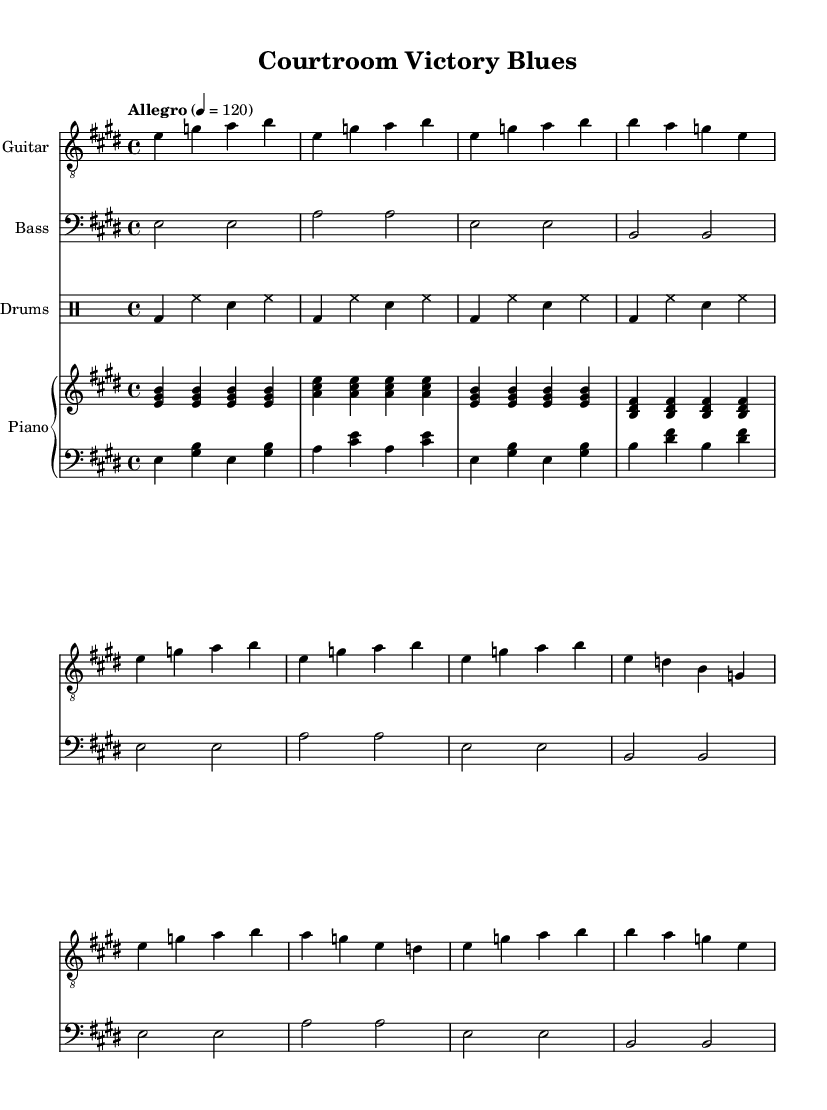What is the key signature of this music? The key signature is E major, which contains four sharps (F#, C#, G#, D#). This can be identified by looking at the key signature notation at the beginning of the staff where the sharps are indicated.
Answer: E major What is the time signature of this music? The time signature is 4/4, meaning there are four beats in each measure and the quarter note gets one beat. This is indicated at the beginning of the sheet music next to the key signature.
Answer: 4/4 What is the tempo marking for this piece? The tempo marking is "Allegro," which indicates a fast-paced, lively speed for the performance. This is stated at the beginning of the music, specifying the desired speed as well.
Answer: Allegro How many measures are there in the verse section? There are four measures in the verse section as represented by four groups of notes and rests notated separately under the guitar staff in that segment.
Answer: Four What style of music is indicated for this piece? The style of music is indicated as Electric Blues, which is clear from the title "Courtroom Victory Blues." The upbeat nature and themes relate to the genre's characteristics.
Answer: Electric Blues What do the lyrics of the chorus celebrate? The lyrics of the chorus celebrate courtroom victories and the journey of hard work and success in the legal profession, highlighting the themes of winning cases and personal accomplishments.
Answer: Courtroom victories What instrument plays the main riff? The main riff is played by the Electric Guitar, which is clearly designated at the top of the respective staff section in the sheet music.
Answer: Electric Guitar 